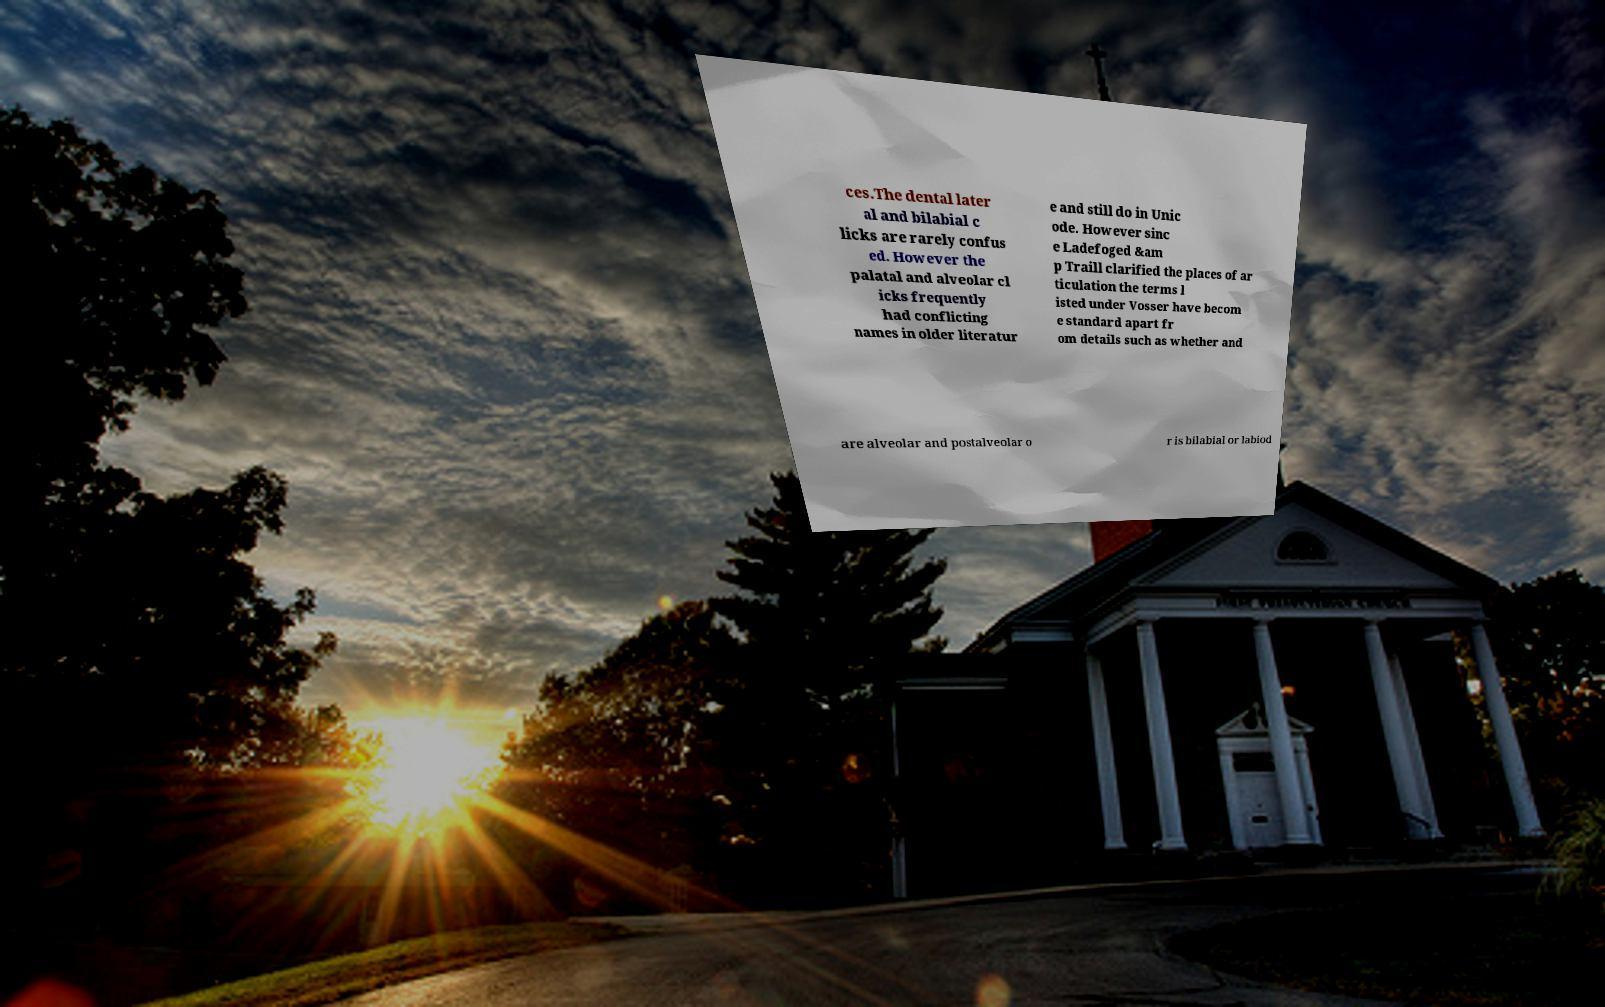Please identify and transcribe the text found in this image. ces.The dental later al and bilabial c licks are rarely confus ed. However the palatal and alveolar cl icks frequently had conflicting names in older literatur e and still do in Unic ode. However sinc e Ladefoged &am p Traill clarified the places of ar ticulation the terms l isted under Vosser have becom e standard apart fr om details such as whether and are alveolar and postalveolar o r is bilabial or labiod 